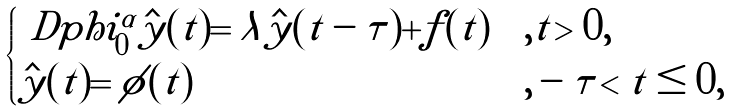Convert formula to latex. <formula><loc_0><loc_0><loc_500><loc_500>\begin{cases} \ D p h i ^ { \alpha } _ { 0 } \hat { y } ( t ) = \lambda \hat { y } ( t - \tau ) + f ( t ) & , t > 0 , \\ \hat { y } ( t ) = \phi ( t ) & , - \tau < t \leq 0 , \end{cases}</formula> 